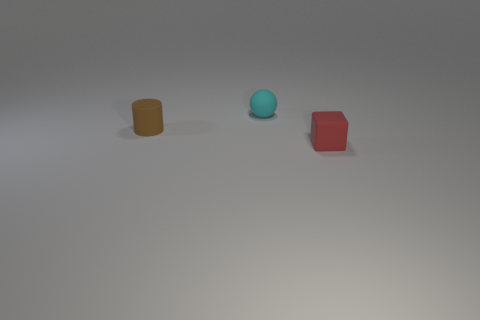Add 2 small matte cylinders. How many objects exist? 5 Add 3 small shiny cylinders. How many small shiny cylinders exist? 3 Subtract 0 cyan cylinders. How many objects are left? 3 Subtract all spheres. How many objects are left? 2 Subtract all yellow metallic cylinders. Subtract all small cyan matte balls. How many objects are left? 2 Add 3 small rubber cylinders. How many small rubber cylinders are left? 4 